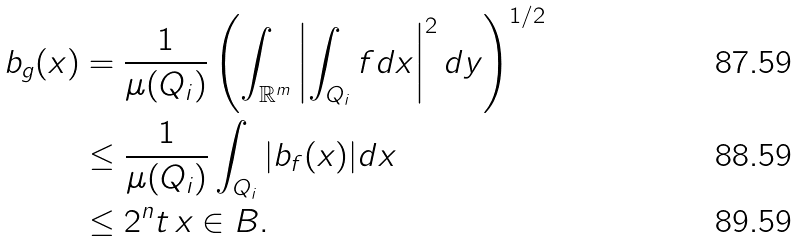Convert formula to latex. <formula><loc_0><loc_0><loc_500><loc_500>b _ { g } ( x ) & = \frac { 1 } { \mu ( Q _ { i } ) } \left ( \int _ { \mathbb { R } ^ { m } } \left | \int _ { Q _ { i } } f d x \right | ^ { 2 } d y \right ) ^ { 1 / 2 } \\ & \leq \frac { 1 } { \mu ( Q _ { i } ) } \int _ { Q _ { i } } | b _ { f } ( x ) | d x \\ & \leq 2 ^ { n } t \, x \in B .</formula> 